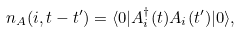<formula> <loc_0><loc_0><loc_500><loc_500>n _ { A } ( i , t - t ^ { \prime } ) = \langle 0 | A ^ { \dagger } _ { i } ( t ) A _ { i } ( t ^ { \prime } ) | 0 \rangle ,</formula> 